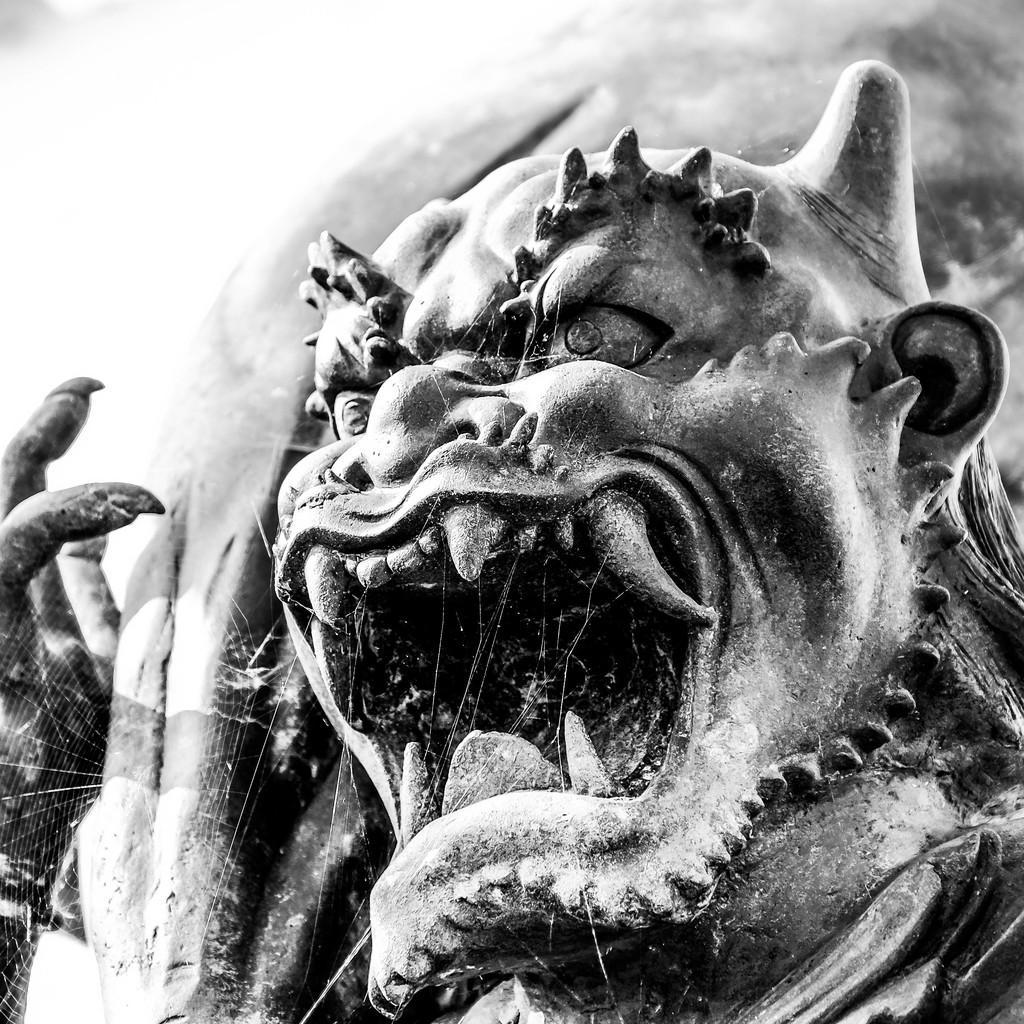Could you give a brief overview of what you see in this image? In this picture we can see statue and spider web. In the background it is not clear. 